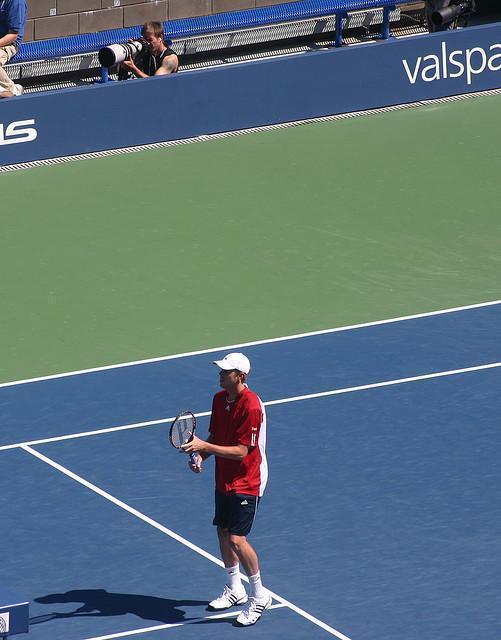How many visible stripes are in his right shoe?
Select the accurate response from the four choices given to answer the question.
Options: Three, zero, one, two. Three. 